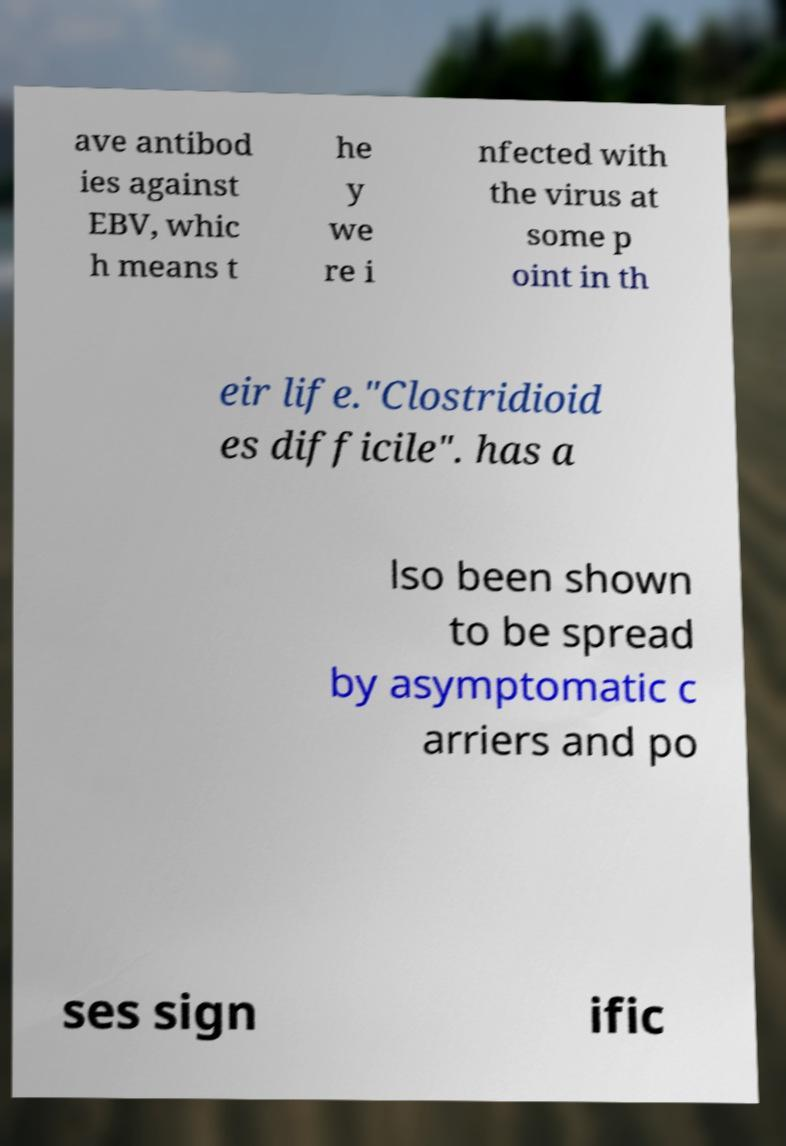For documentation purposes, I need the text within this image transcribed. Could you provide that? ave antibod ies against EBV, whic h means t he y we re i nfected with the virus at some p oint in th eir life."Clostridioid es difficile". has a lso been shown to be spread by asymptomatic c arriers and po ses sign ific 